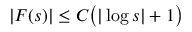Convert formula to latex. <formula><loc_0><loc_0><loc_500><loc_500>| F ( s ) | \leq C \left ( | \log s | + 1 \right )</formula> 